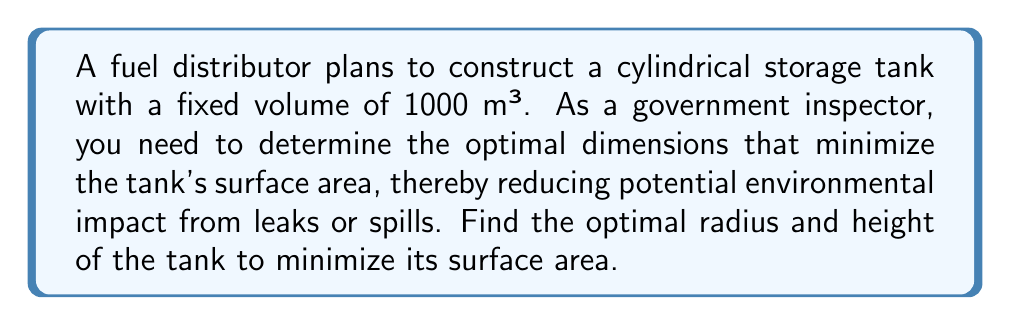Teach me how to tackle this problem. Let's approach this step-by-step:

1) Let $r$ be the radius and $h$ be the height of the cylinder.

2) The volume of a cylinder is given by $V = \pi r^2 h$. We know $V = 1000$ m³, so:

   $$1000 = \pi r^2 h$$

3) The surface area of a cylinder (including top and bottom) is given by:

   $$A = 2\pi r^2 + 2\pi rh$$

4) We need to express $h$ in terms of $r$ using the volume equation:

   $$h = \frac{1000}{\pi r^2}$$

5) Substituting this into the surface area equation:

   $$A = 2\pi r^2 + 2\pi r(\frac{1000}{\pi r^2}) = 2\pi r^2 + \frac{2000}{r}$$

6) To find the minimum surface area, we differentiate $A$ with respect to $r$ and set it to zero:

   $$\frac{dA}{dr} = 4\pi r - \frac{2000}{r^2} = 0$$

7) Solving this equation:

   $$4\pi r^3 = 2000$$
   $$r^3 = \frac{500}{\pi}$$
   $$r = \sqrt[3]{\frac{500}{\pi}} \approx 5.42$$

8) Now we can find $h$ using the equation from step 4:

   $$h = \frac{1000}{\pi (5.42)^2} \approx 10.84$$

9) To verify this is a minimum, we can check the second derivative is positive at this point (omitted for brevity).

[asy]
import graph;
size(200);
real r = 5.42;
real h = 10.84;
draw(circle((0,0),r));
draw((r,0)--(r,h));
draw((-r,0)--(-r,h));
draw(circle((0,h),r));
draw((0,0)--(r,0),arrow=Arrow);
label("r",(r/2,0),S);
draw((r,0)--(r,h),arrow=Arrow);
label("h",(r,h/2),E);
[/asy]
Answer: $r \approx 5.42$ m, $h \approx 10.84$ m 